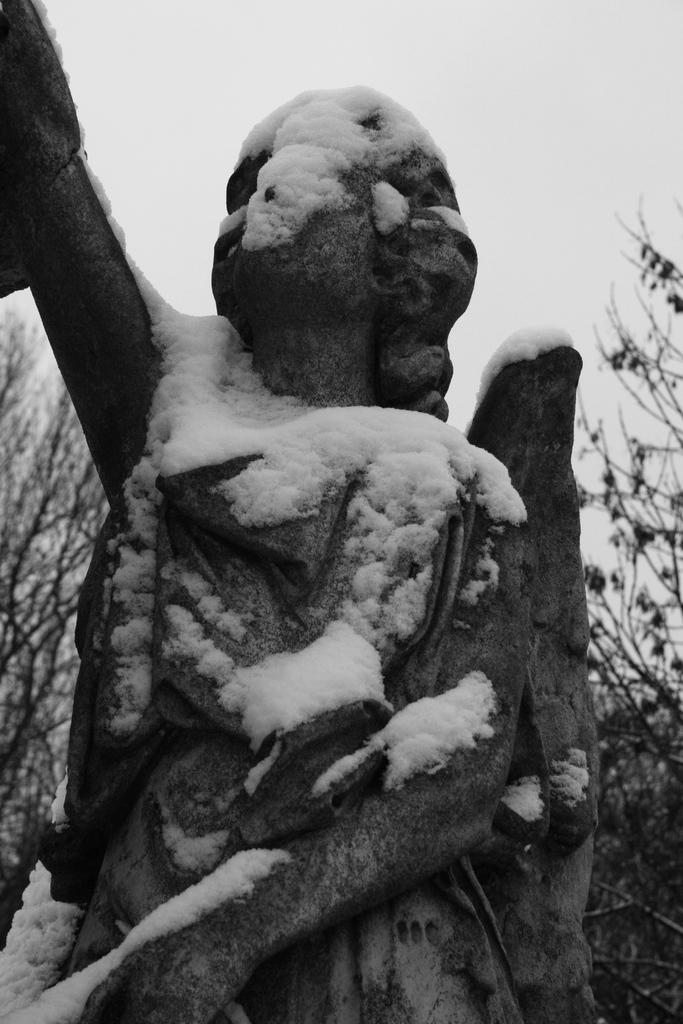What is the main subject of the image? There is a sculpture in the image. How is the sculpture affected by the weather? The sculpture is covered by snow. What can be seen in the background of the image? There are trees and the sky visible in the background of the image. What type of whip can be seen in the hands of the beggar in the image? There is no beggar or whip present in the image; it features a sculpture covered by snow with trees and the sky in the background. 